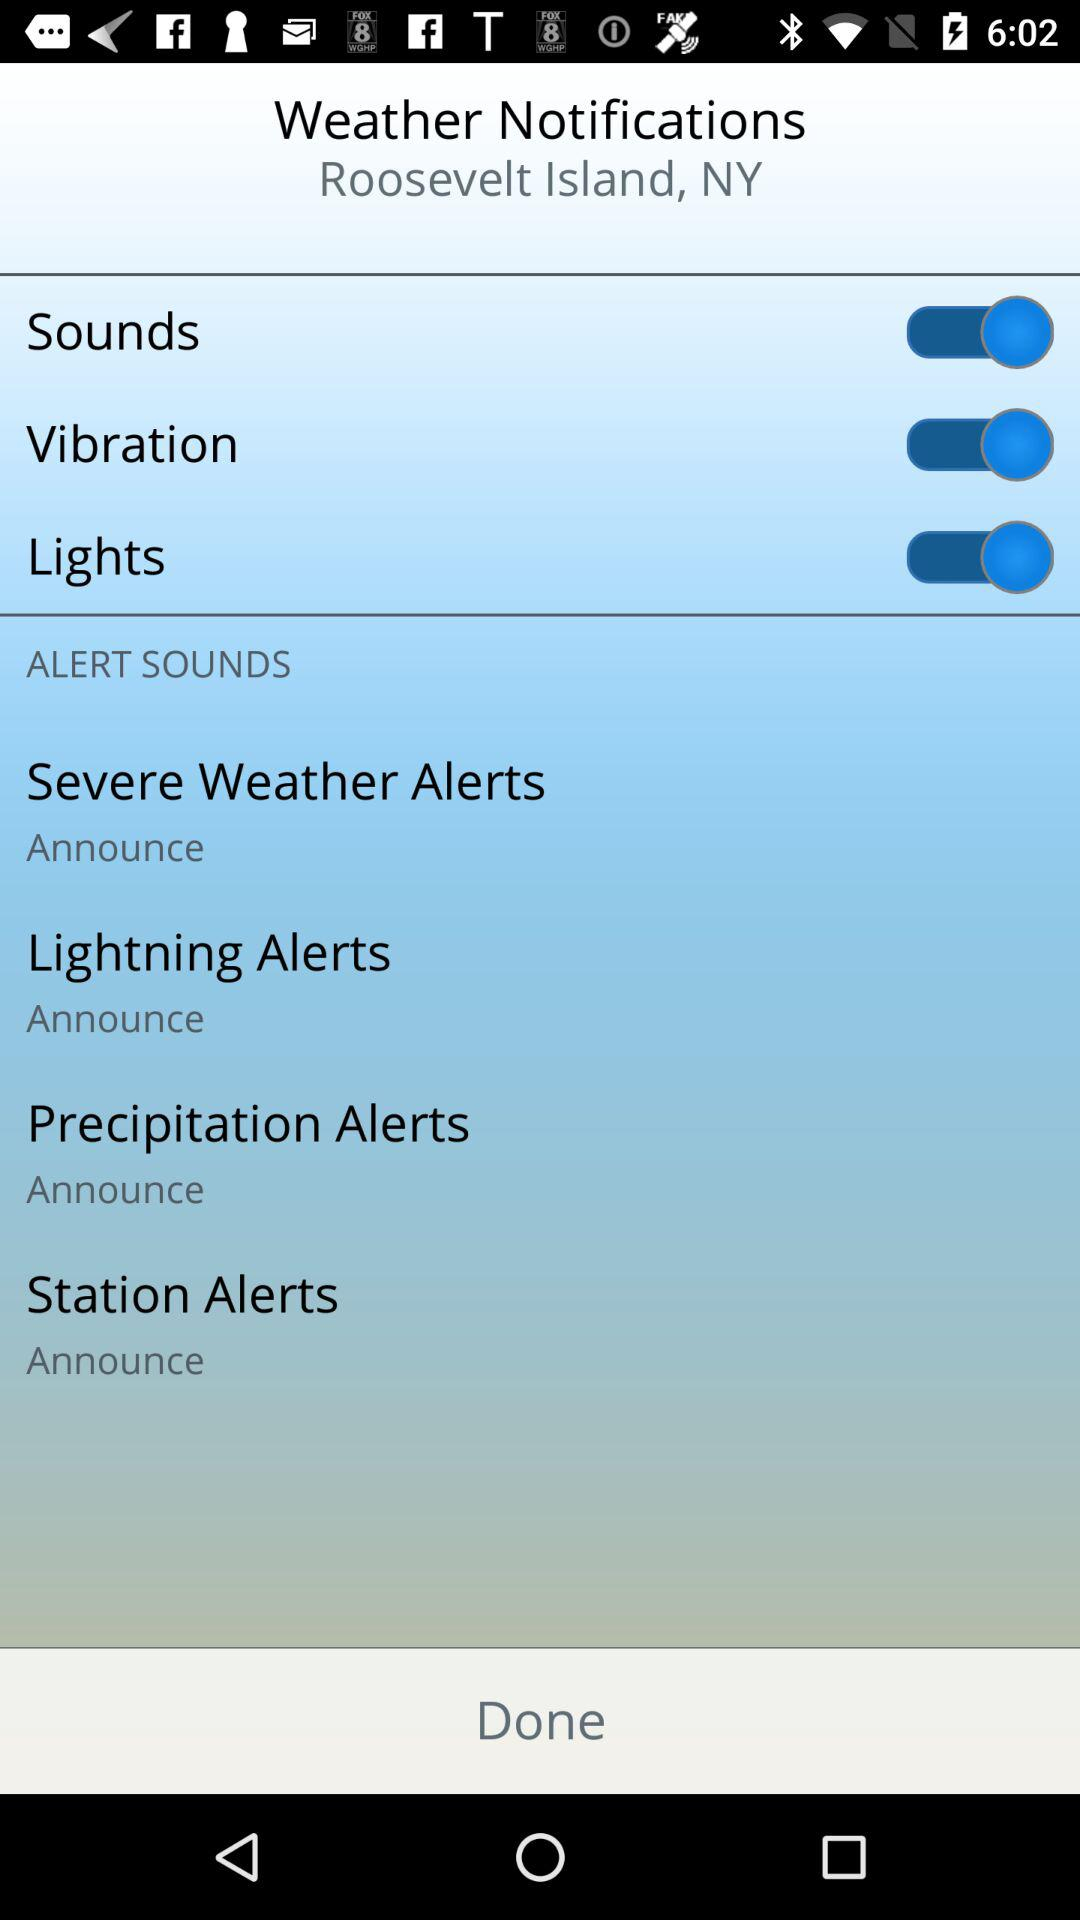How many alerts have an announce option?
Answer the question using a single word or phrase. 4 